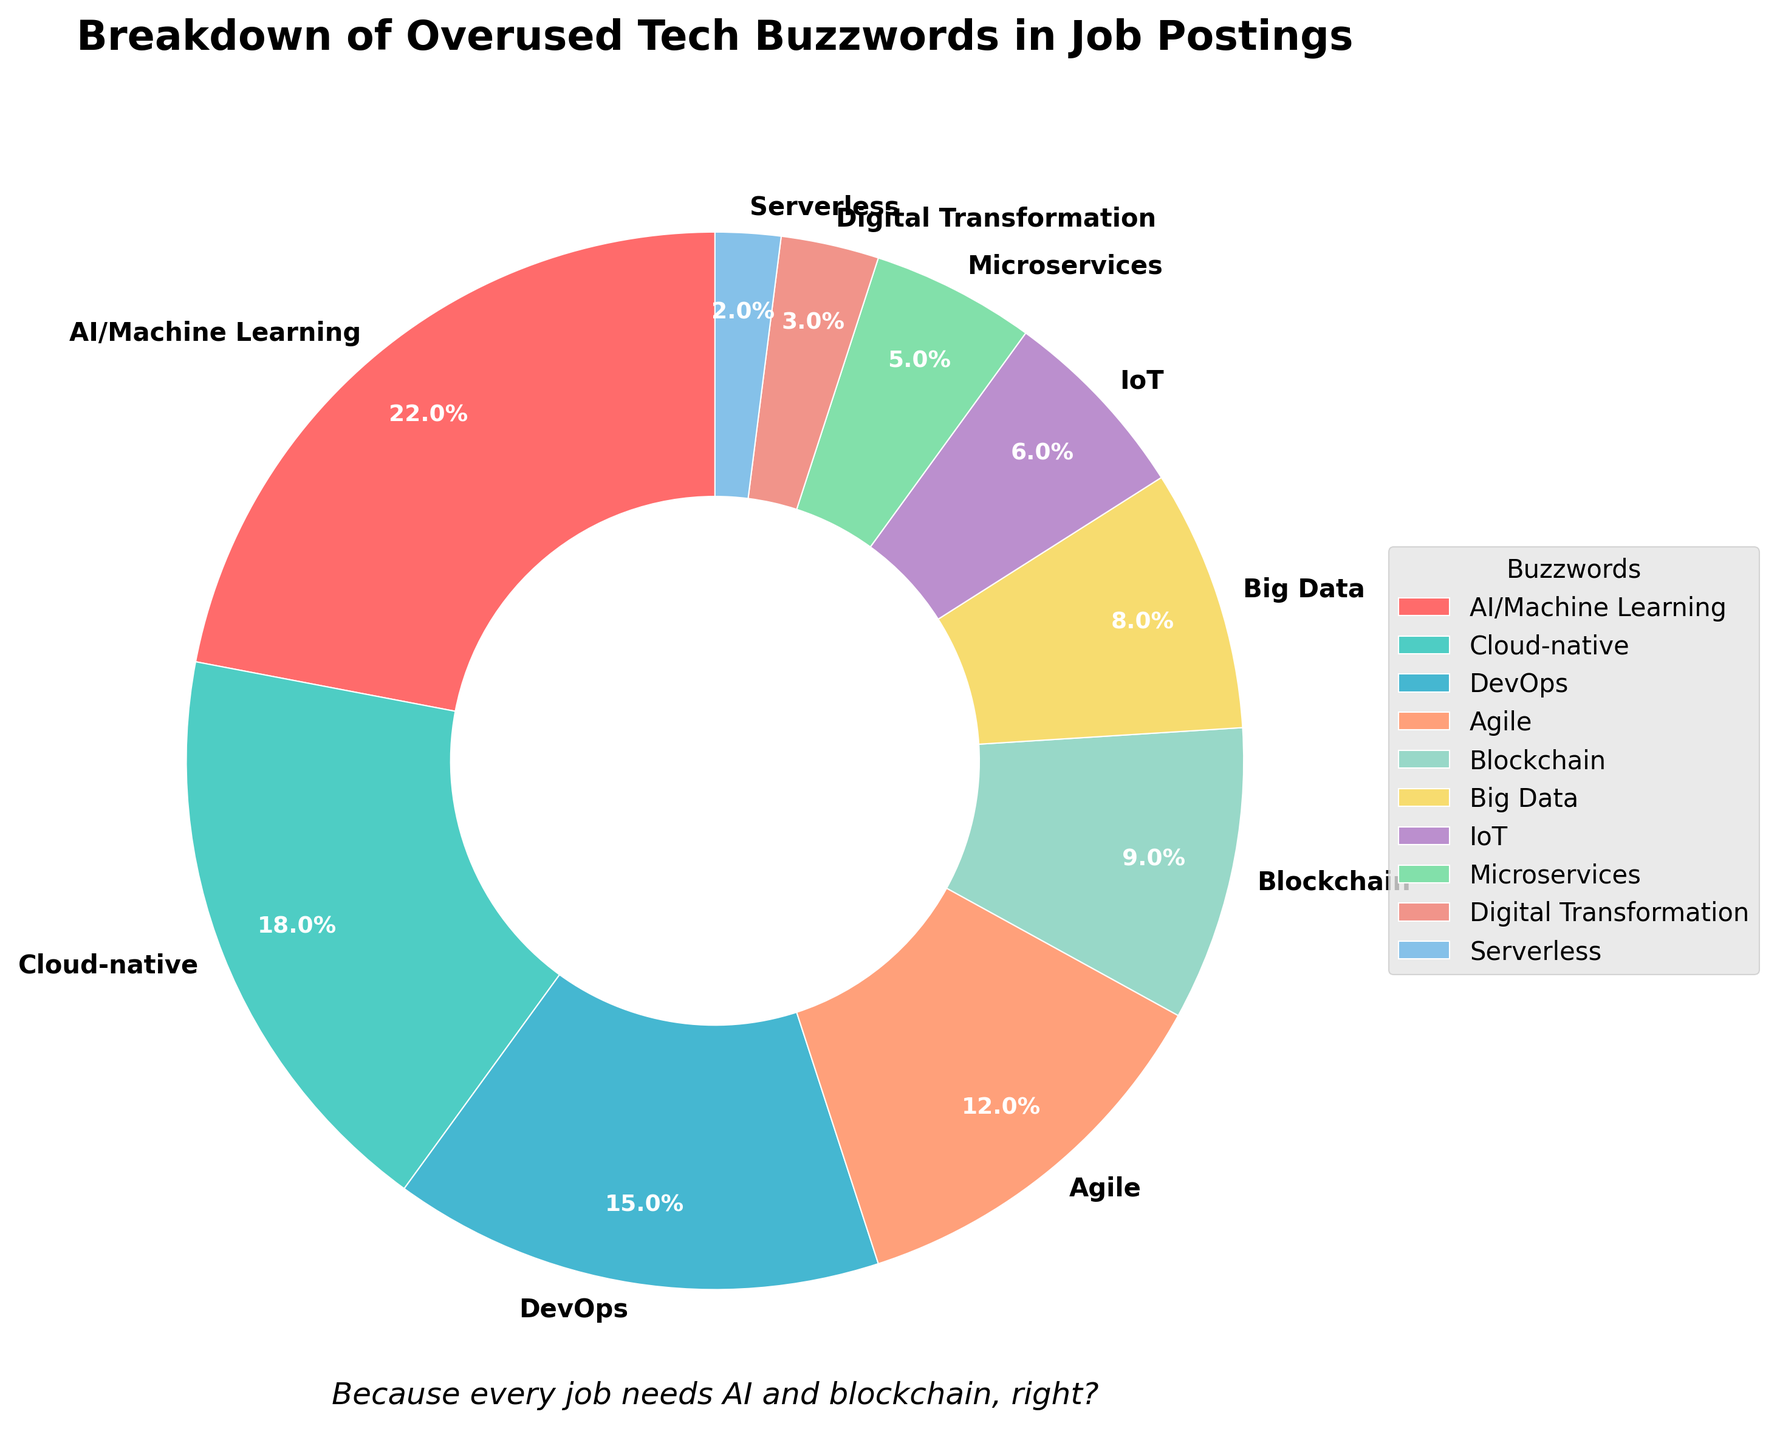What's the most overused tech buzzword in job postings? The pie chart clearly shows that "AI/Machine Learning" has the largest section, taking up 22% of the pie.
Answer: AI/Machine Learning Which buzzword has the smallest percentage in job postings? The section labeled "Serverless" takes up the smallest slice of the pie at 2%.
Answer: Serverless What is the combined percentage of the top three buzzwords? The percentages for the top three buzzwords are 22% (AI/Machine Learning), 18% (Cloud-native), and 15% (DevOps). Summing these up gives 22 + 18 + 15 = 55%.
Answer: 55% Is "Agile" more or less overused than "DevOps"? The chart shows "DevOps" at 15% and "Agile" at 12%. Since 15% is greater than 12%, "DevOps" is more overused than "Agile".
Answer: More If you sum the percentages of "Blockchain", "Big Data", and "IoT", what do you get? "Blockchain" is 9%, "Big Data" is 8%, and "IoT" is 6%. Summing these gives 9 + 8 + 6 = 23%.
Answer: 23% How many buzzwords individually have a percentage of 10% or higher? "AI/Machine Learning" (22%), "Cloud-native" (18%), and "DevOps" (15%), and "Agile" (12%), are all above 10%. There are four such buzzwords.
Answer: 4 Among "Microservices", "Digital Transformation", and "Serverless", which one is the least overused? The chart indicates that "Serverless" has the smallest section at 2%.
Answer: Serverless By how much does "Cloud-native" exceed "Big Data" in percentage points? "Cloud-native" is at 18% and "Big Data" is at 8%. The difference is 18 - 8 = 10 percentage points.
Answer: 10 What's the total percentage covered by buzzwords related to data (AI/Machine Learning, Big Data)? "AI/Machine Learning" is 22% and "Big Data" is 8%. Adding these gives 22 + 8 = 30%.
Answer: 30% Which buzzwords are shown in green and blue? Green is used for "Cloud-native" and blue for "DevOps".
Answer: Cloud-native, DevOps 